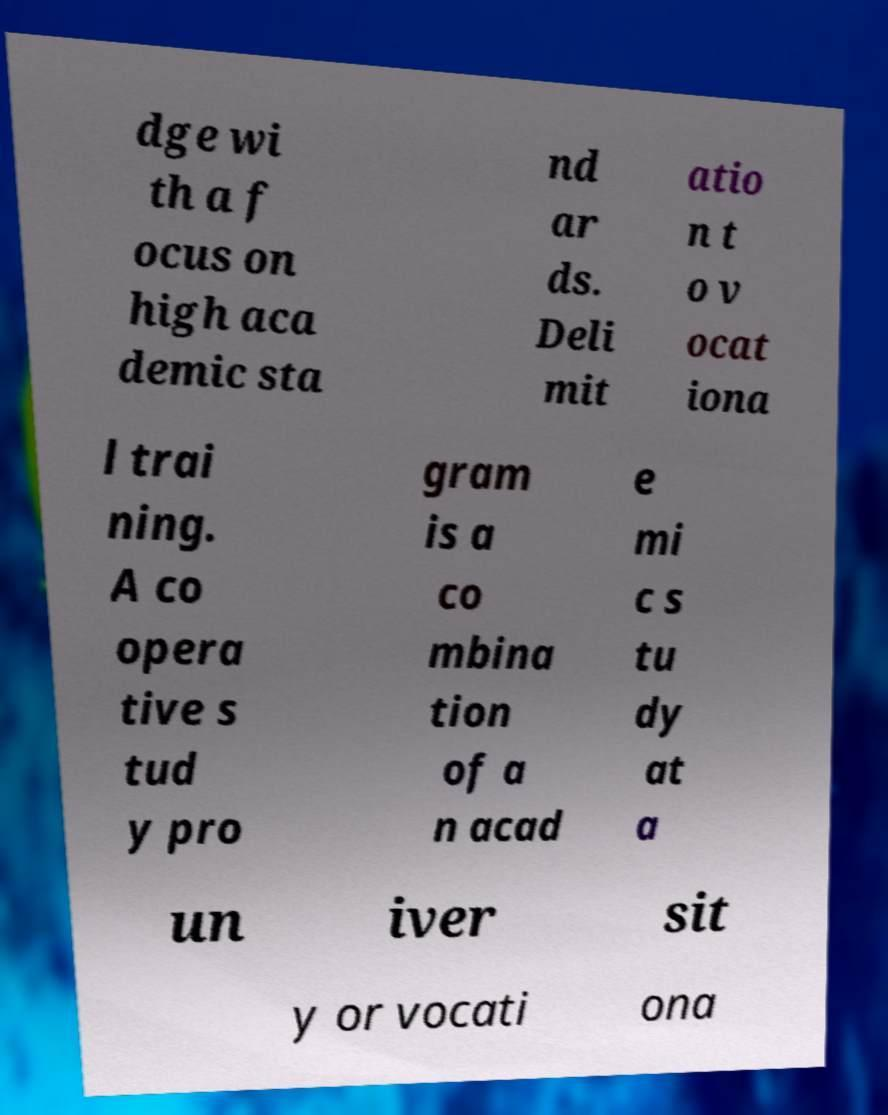For documentation purposes, I need the text within this image transcribed. Could you provide that? dge wi th a f ocus on high aca demic sta nd ar ds. Deli mit atio n t o v ocat iona l trai ning. A co opera tive s tud y pro gram is a co mbina tion of a n acad e mi c s tu dy at a un iver sit y or vocati ona 